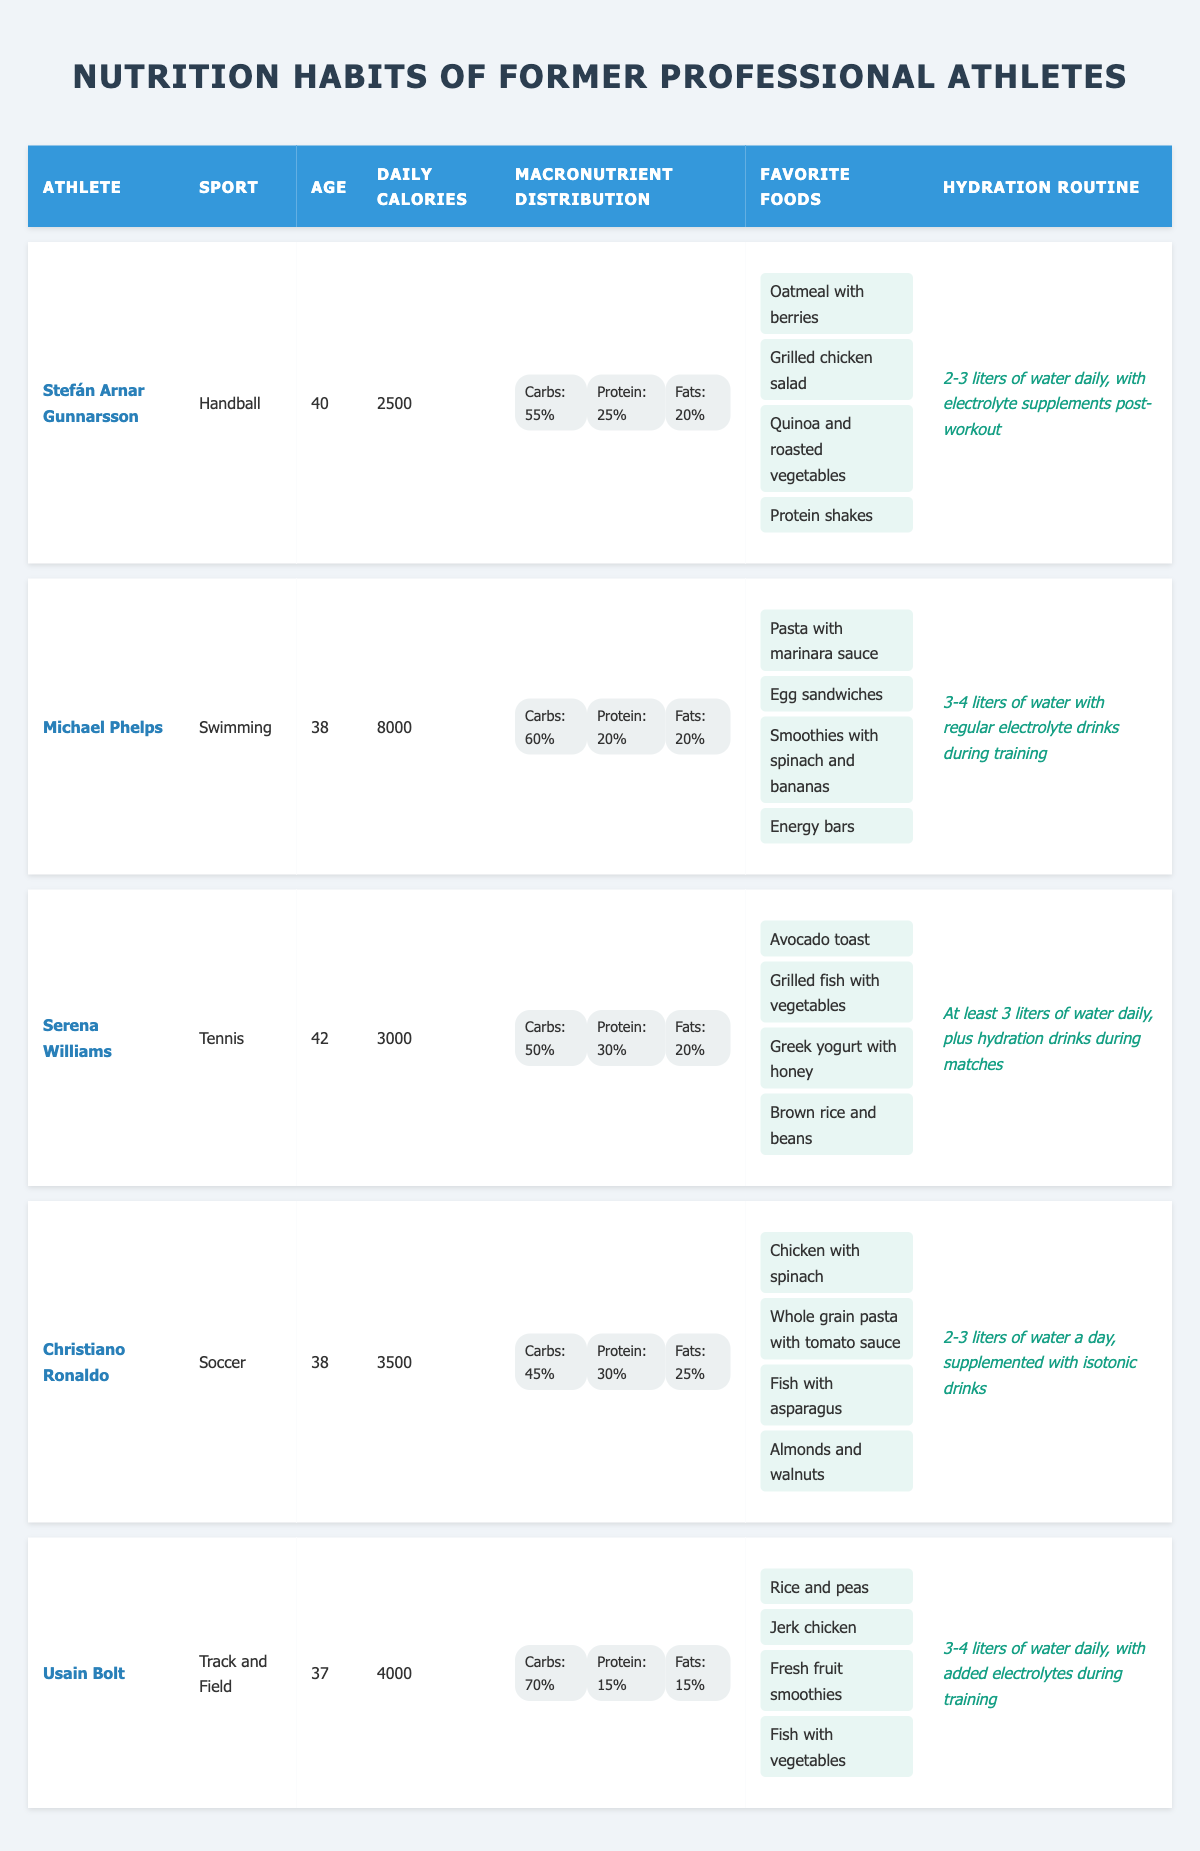What is the daily caloric intake of Stefán Arnar Gunnarsson? Looking at the table, the row corresponding to Stefán Arnar Gunnarsson shows that his daily caloric intake is listed as 2500.
Answer: 2500 Which athlete consumes the highest daily calories? In the table, comparing the daily caloric intake values, Michael Phelps has the highest intake of 8000 calories, which is more than any other athlete listed.
Answer: Michael Phelps What percentage of daily calories does Usain Bolt get from carbohydrates? By checking Usain Bolt's row in the table, it indicates that he gets 70% of his daily caloric intake from carbohydrates.
Answer: 70% Is the hydration routine for Serena Williams more than 3 liters daily? Looking at Serena Williams' hydration routine, it states that she consumes at least 3 liters of water daily, which confirms the requirements.
Answer: Yes What is the average daily caloric intake of all athletes listed? First, we sum the daily caloric intakes: (2500 + 8000 + 3000 + 3500 + 4000) = 21000. Next, we divide by the number of athletes, which is 5: 21000 / 5 = 4200.
Answer: 4200 How many athletes have a protein intake percentage of at least 25%? By examining the table, we find that Stefán Arnar Gunnarsson (25%), Serena Williams (30%), Christiano Ronaldo (30%), and others also meet the criteria, totaling four athletes.
Answer: Four athletes What is the unique favorite food of Michael Phelps that is not listed as a favorite food for any other athlete? In the table, Michael Phelps has "Egg sandwiches" listed as a favorite food. Checking the other athletes' favorite foods confirms that this item is not mentioned anywhere else.
Answer: Egg sandwiches Is the fat distribution for Christiano Ronaldo greater than 20%? Looking at Christiano Ronaldo's row, he has a fat distribution of 25%, which is indeed greater than 20%.
Answer: Yes Which athlete has the lowest caloric intake and what sport do they play? Assessing the daily caloric intake values in the table reveals that Stefán Arnar Gunnarsson has the lowest at 2500 calories, and he plays handball.
Answer: Stefán Arnar Gunnarsson, Handball 